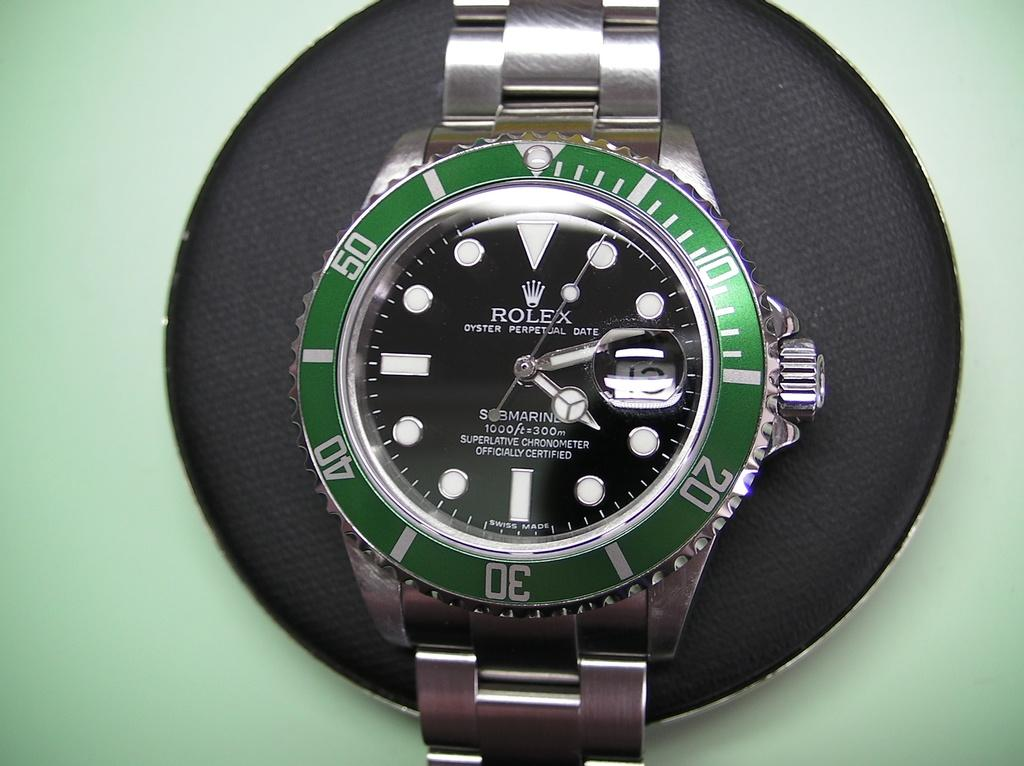<image>
Present a compact description of the photo's key features. A silver and green Rolex wrist watch is being displayed on a black, disc shaped, holster. 